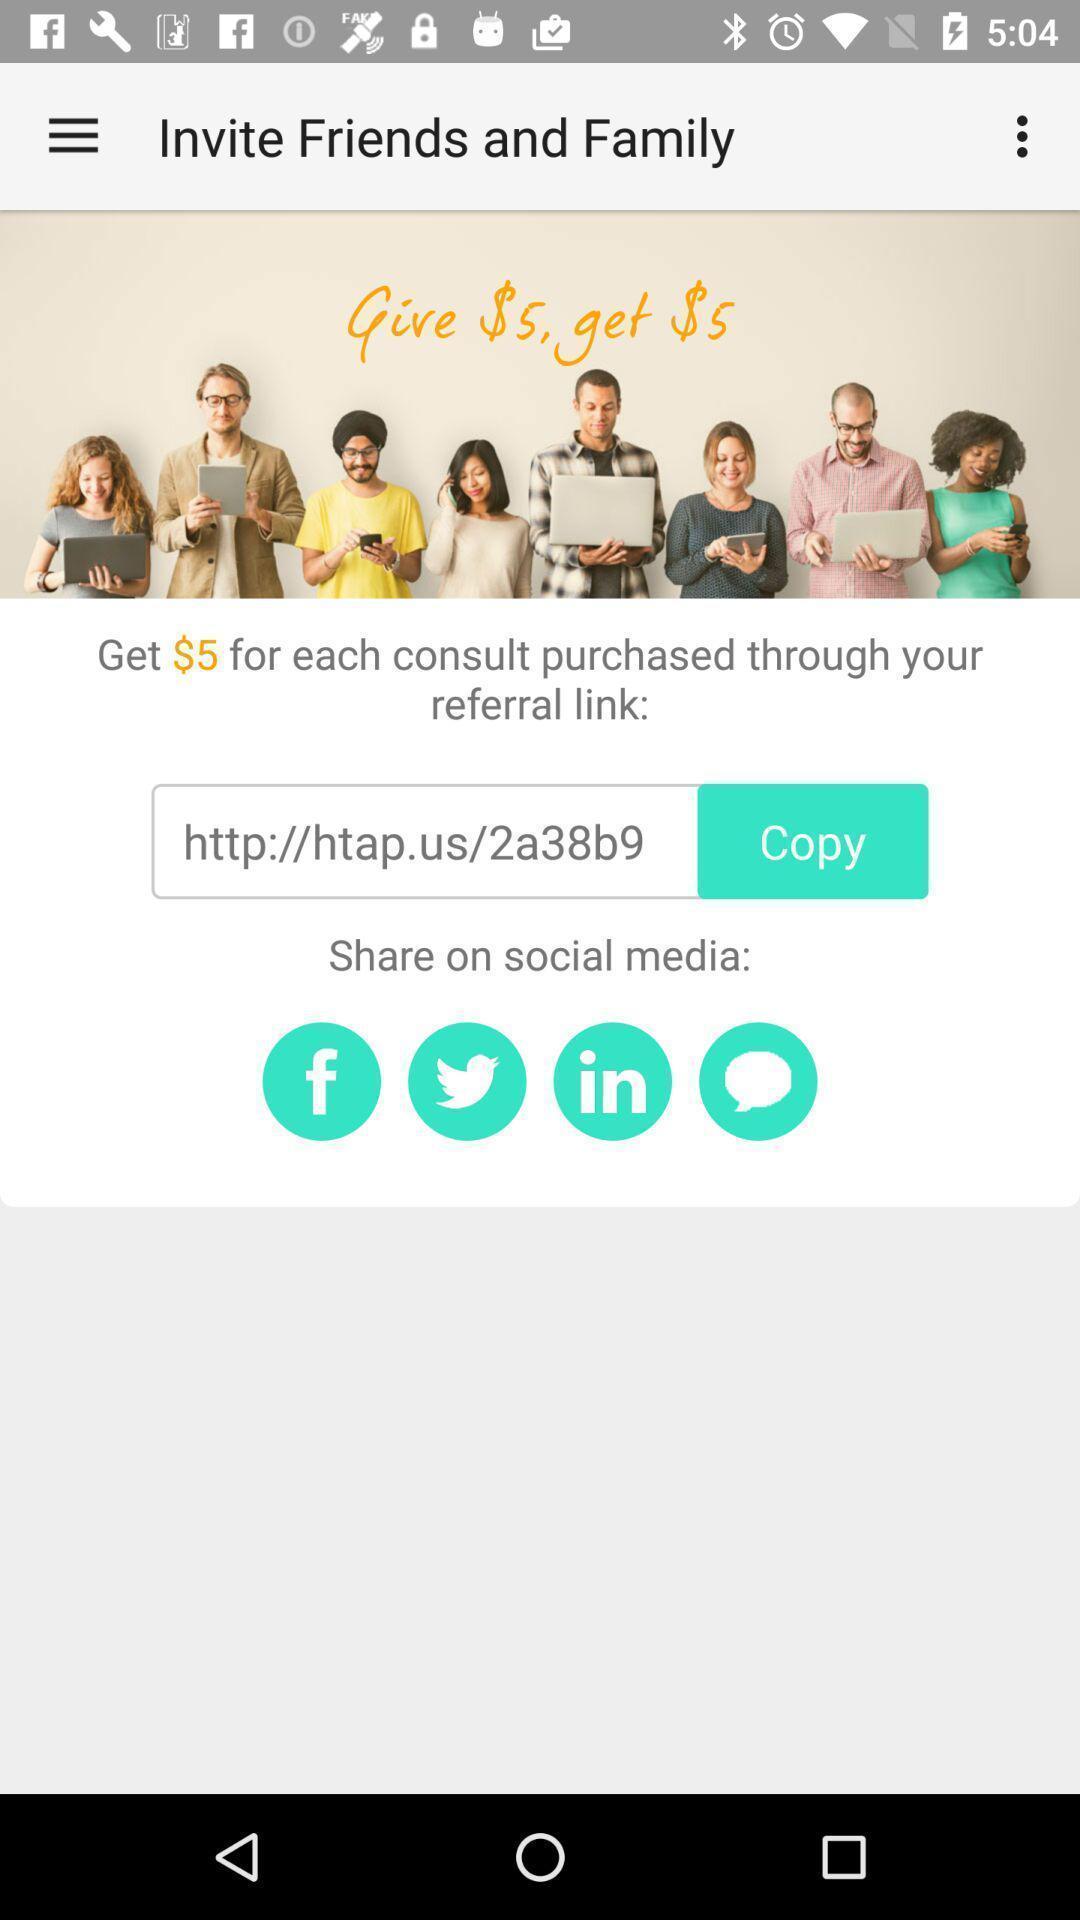Describe this image in words. Screen displaying the referral page. 